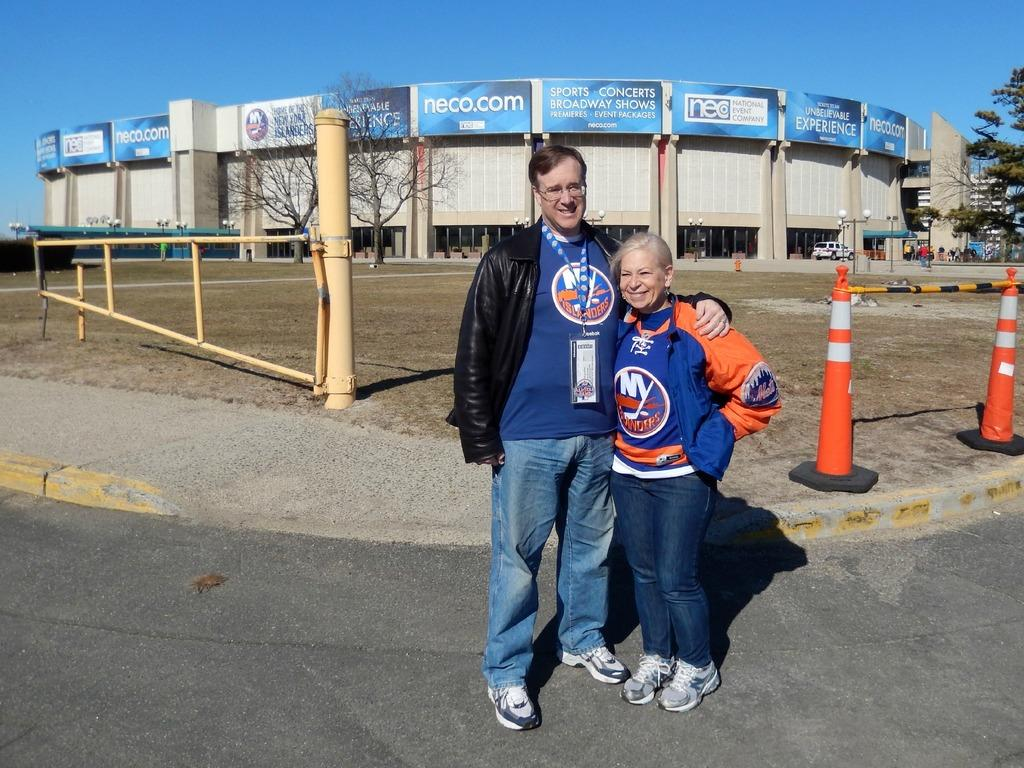<image>
Offer a succinct explanation of the picture presented. The jersey being worn here is for the New York Islanders 